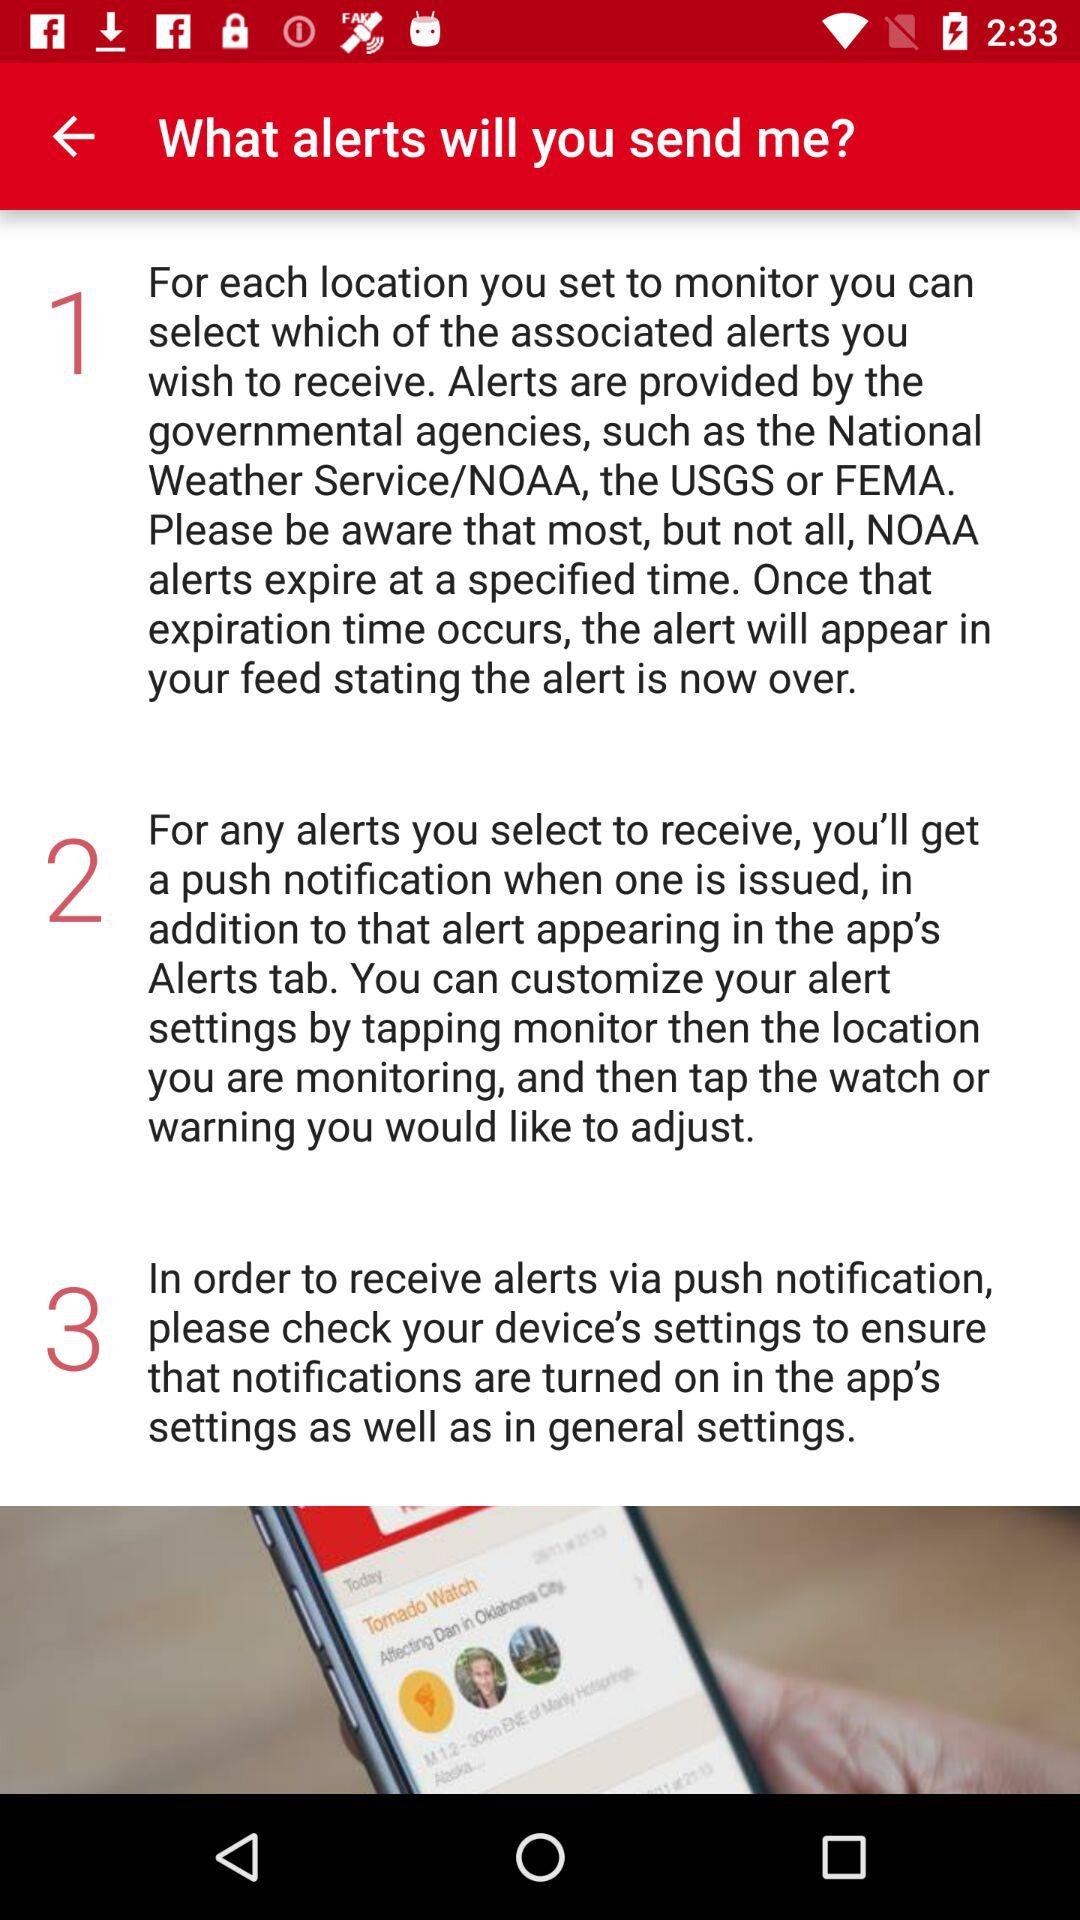How many steps are there in the process of receiving alerts?
Answer the question using a single word or phrase. 3 